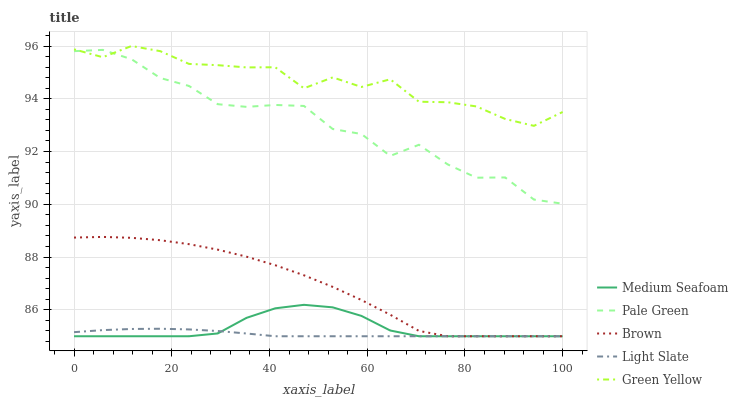Does Brown have the minimum area under the curve?
Answer yes or no. No. Does Brown have the maximum area under the curve?
Answer yes or no. No. Is Brown the smoothest?
Answer yes or no. No. Is Brown the roughest?
Answer yes or no. No. Does Green Yellow have the lowest value?
Answer yes or no. No. Does Brown have the highest value?
Answer yes or no. No. Is Brown less than Pale Green?
Answer yes or no. Yes. Is Pale Green greater than Brown?
Answer yes or no. Yes. Does Brown intersect Pale Green?
Answer yes or no. No. 